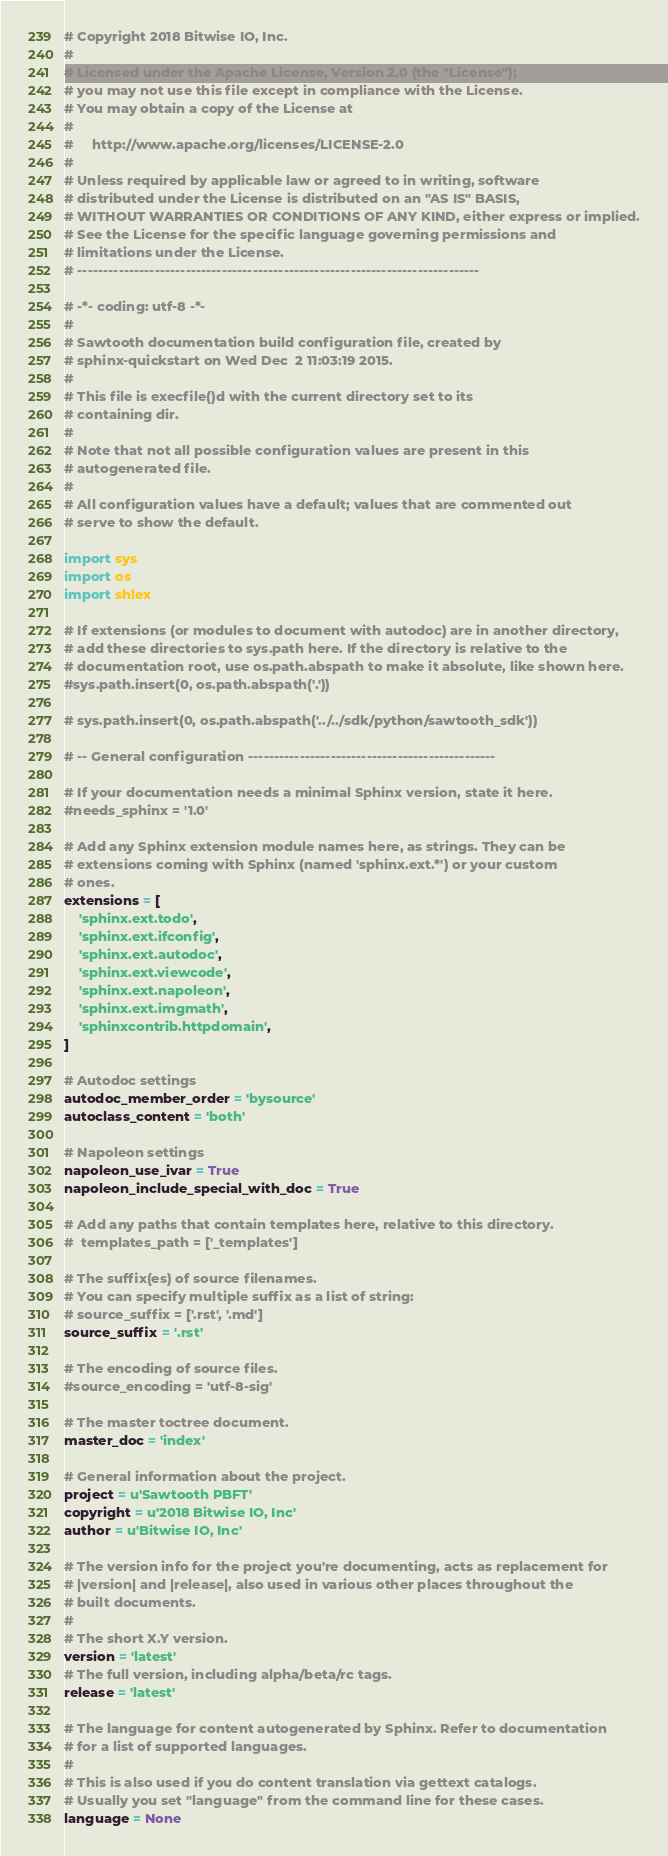Convert code to text. <code><loc_0><loc_0><loc_500><loc_500><_Python_># Copyright 2018 Bitwise IO, Inc.
#
# Licensed under the Apache License, Version 2.0 (the "License");
# you may not use this file except in compliance with the License.
# You may obtain a copy of the License at
#
#     http://www.apache.org/licenses/LICENSE-2.0
#
# Unless required by applicable law or agreed to in writing, software
# distributed under the License is distributed on an "AS IS" BASIS,
# WITHOUT WARRANTIES OR CONDITIONS OF ANY KIND, either express or implied.
# See the License for the specific language governing permissions and
# limitations under the License.
# ------------------------------------------------------------------------------

# -*- coding: utf-8 -*-
#
# Sawtooth documentation build configuration file, created by
# sphinx-quickstart on Wed Dec  2 11:03:19 2015.
#
# This file is execfile()d with the current directory set to its
# containing dir.
#
# Note that not all possible configuration values are present in this
# autogenerated file.
#
# All configuration values have a default; values that are commented out
# serve to show the default.

import sys
import os
import shlex

# If extensions (or modules to document with autodoc) are in another directory,
# add these directories to sys.path here. If the directory is relative to the
# documentation root, use os.path.abspath to make it absolute, like shown here.
#sys.path.insert(0, os.path.abspath('.'))

# sys.path.insert(0, os.path.abspath('../../sdk/python/sawtooth_sdk'))

# -- General configuration ------------------------------------------------

# If your documentation needs a minimal Sphinx version, state it here.
#needs_sphinx = '1.0'

# Add any Sphinx extension module names here, as strings. They can be
# extensions coming with Sphinx (named 'sphinx.ext.*') or your custom
# ones.
extensions = [
    'sphinx.ext.todo',
    'sphinx.ext.ifconfig',
    'sphinx.ext.autodoc',
    'sphinx.ext.viewcode',
    'sphinx.ext.napoleon',
    'sphinx.ext.imgmath',
    'sphinxcontrib.httpdomain',
]

# Autodoc settings
autodoc_member_order = 'bysource'
autoclass_content = 'both'

# Napoleon settings
napoleon_use_ivar = True
napoleon_include_special_with_doc = True

# Add any paths that contain templates here, relative to this directory.
#  templates_path = ['_templates']

# The suffix(es) of source filenames.
# You can specify multiple suffix as a list of string:
# source_suffix = ['.rst', '.md']
source_suffix = '.rst'

# The encoding of source files.
#source_encoding = 'utf-8-sig'

# The master toctree document.
master_doc = 'index'

# General information about the project.
project = u'Sawtooth PBFT'
copyright = u'2018 Bitwise IO, Inc'
author = u'Bitwise IO, Inc'

# The version info for the project you're documenting, acts as replacement for
# |version| and |release|, also used in various other places throughout the
# built documents.
#
# The short X.Y version.
version = 'latest'
# The full version, including alpha/beta/rc tags.
release = 'latest'

# The language for content autogenerated by Sphinx. Refer to documentation
# for a list of supported languages.
#
# This is also used if you do content translation via gettext catalogs.
# Usually you set "language" from the command line for these cases.
language = None
</code> 